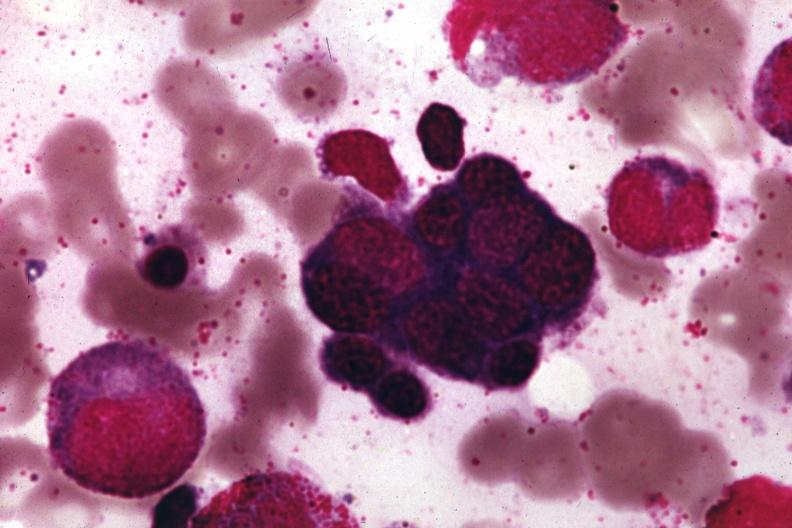what is present?
Answer the question using a single word or phrase. Hematologic 